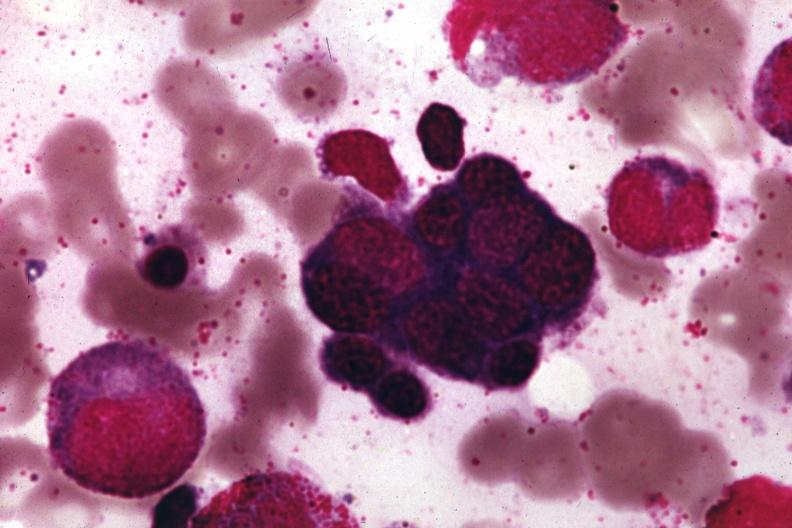what is present?
Answer the question using a single word or phrase. Hematologic 